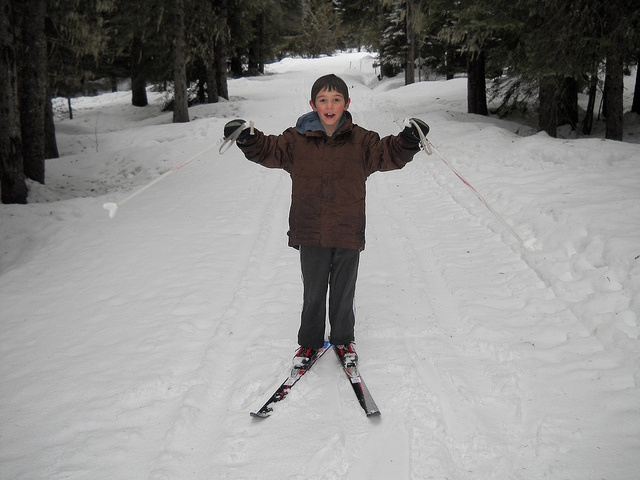Describe the objects in this image and their specific colors. I can see people in black, gray, and brown tones and skis in black, darkgray, gray, and lightgray tones in this image. 